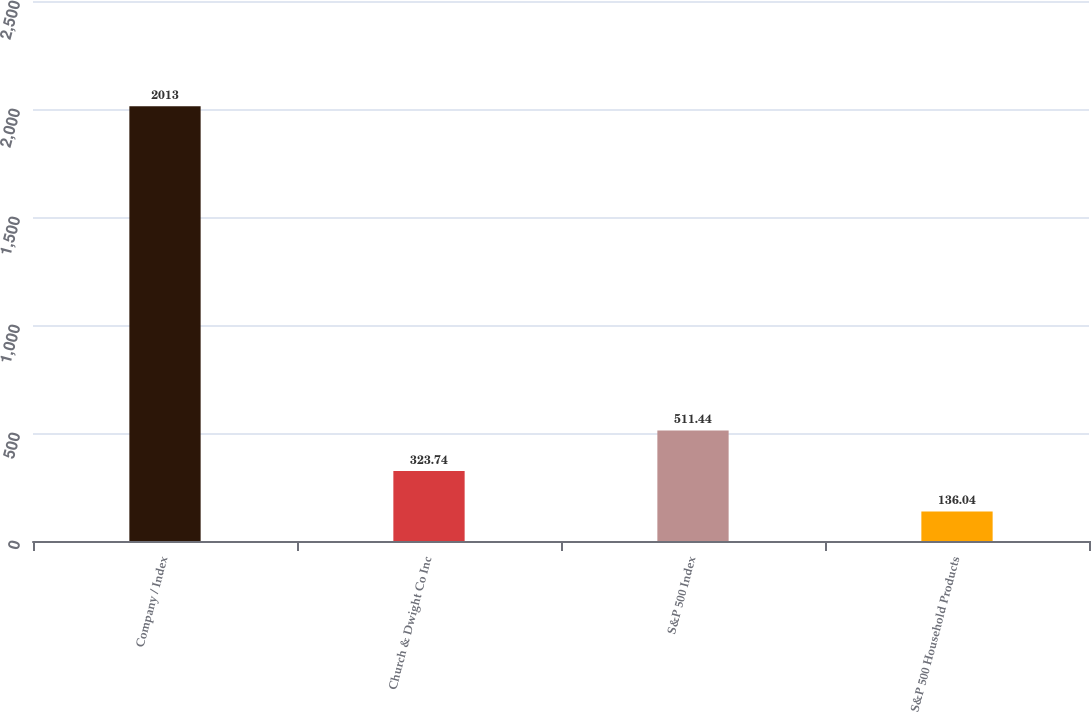Convert chart. <chart><loc_0><loc_0><loc_500><loc_500><bar_chart><fcel>Company / Index<fcel>Church & Dwight Co Inc<fcel>S&P 500 Index<fcel>S&P 500 Household Products<nl><fcel>2013<fcel>323.74<fcel>511.44<fcel>136.04<nl></chart> 